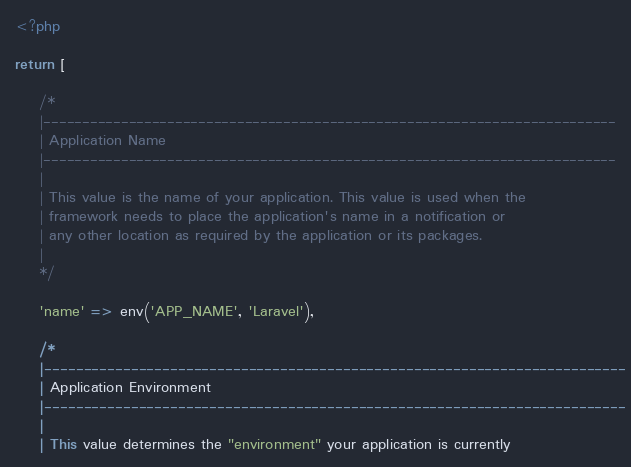Convert code to text. <code><loc_0><loc_0><loc_500><loc_500><_PHP_><?php

return [

    /*
    |--------------------------------------------------------------------------
    | Application Name
    |--------------------------------------------------------------------------
    |
    | This value is the name of your application. This value is used when the
    | framework needs to place the application's name in a notification or
    | any other location as required by the application or its packages.
    |
    */

    'name' => env('APP_NAME', 'Laravel'),

    /*
    |--------------------------------------------------------------------------
    | Application Environment
    |--------------------------------------------------------------------------
    |
    | This value determines the "environment" your application is currently</code> 